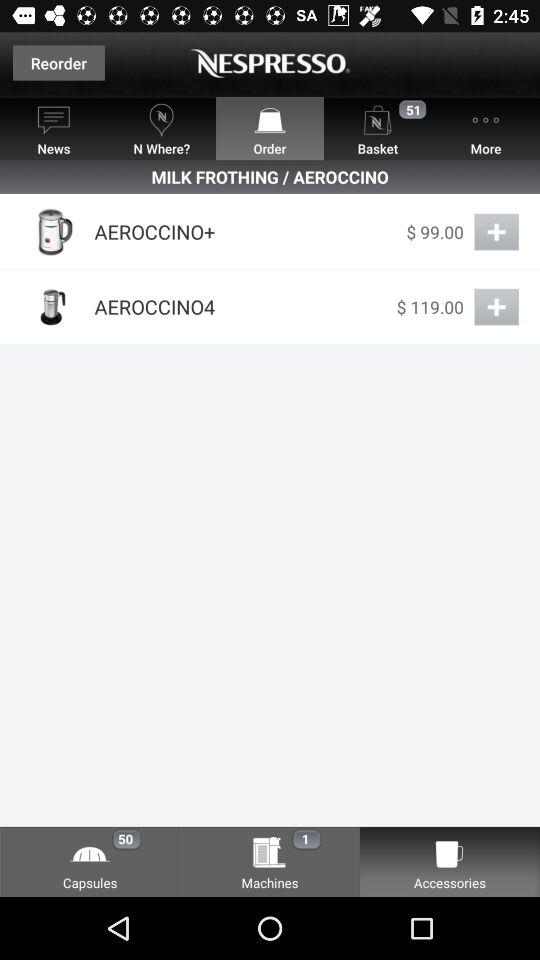What is the currency for the price? The currency is $. 